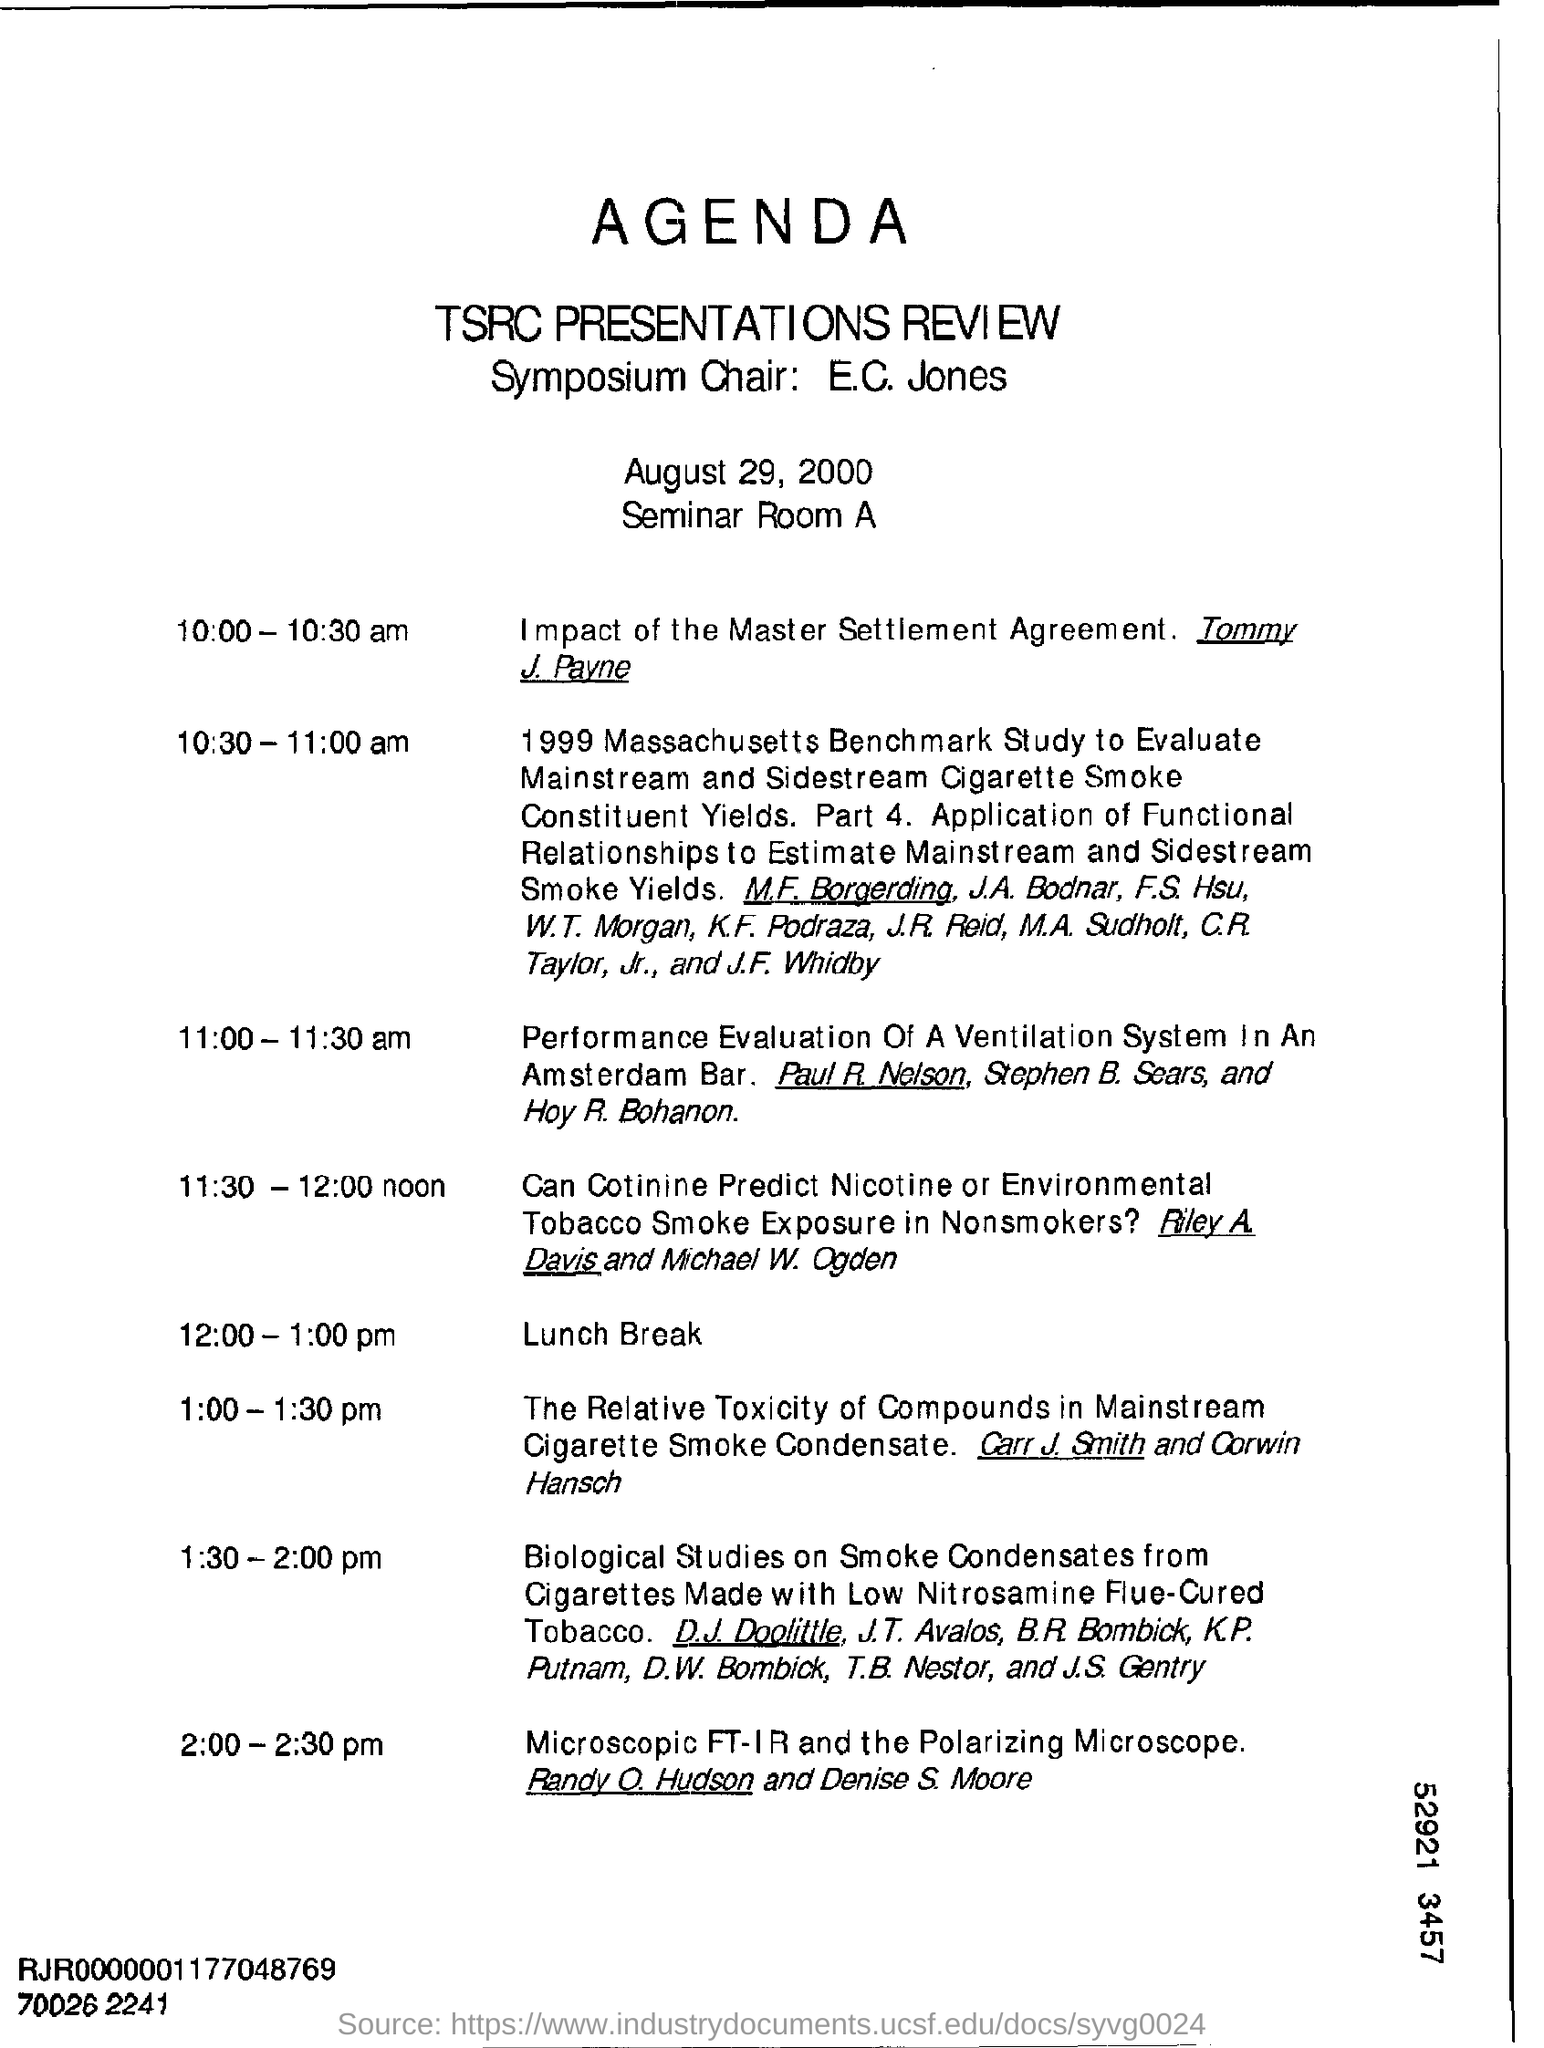Identify some key points in this picture. The item scheduled during the 12:00 - 1:00 pm time slot is a lunch break. The date mentioned is August 29, 2000. 